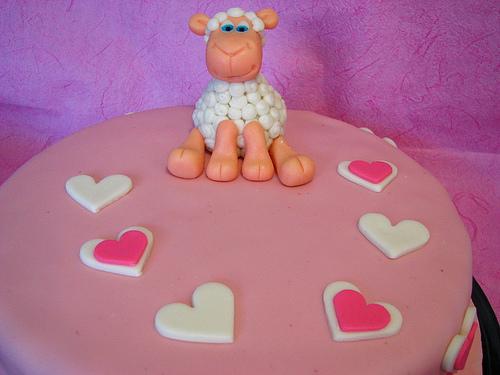What is the shape on the cake?
Give a very brief answer. Round. Is this a marzipan cake?
Give a very brief answer. Yes. Is that animal made of pastry fondant?
Concise answer only. Yes. 